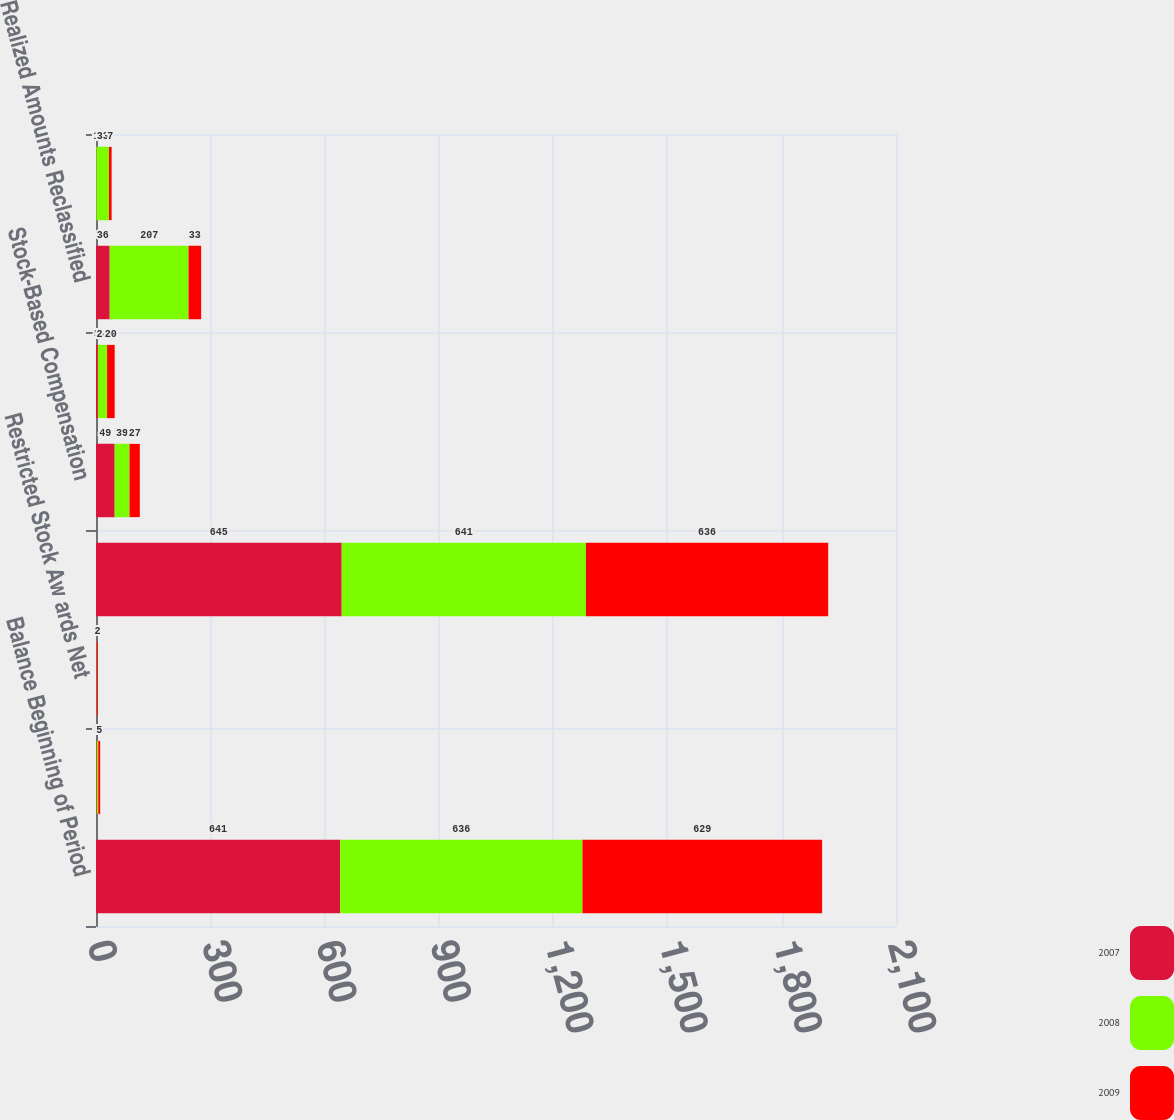<chart> <loc_0><loc_0><loc_500><loc_500><stacked_bar_chart><ecel><fcel>Balance Beginning of Period<fcel>Exercise of Stock Options<fcel>Restricted Stock Aw ards Net<fcel>Balance End of Period<fcel>Stock-Based Compensation<fcel>Tax Benefits Related to<fcel>Realized Amounts Reclassified<fcel>Net Change in Other<nl><fcel>2007<fcel>641<fcel>2<fcel>2<fcel>645<fcel>49<fcel>5<fcel>36<fcel>1<nl><fcel>2008<fcel>636<fcel>4<fcel>1<fcel>641<fcel>39<fcel>24<fcel>207<fcel>33<nl><fcel>2009<fcel>629<fcel>5<fcel>2<fcel>636<fcel>27<fcel>20<fcel>33<fcel>7<nl></chart> 